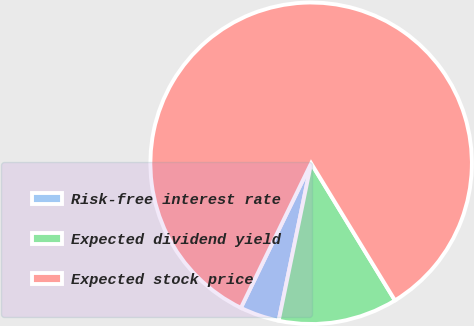Convert chart to OTSL. <chart><loc_0><loc_0><loc_500><loc_500><pie_chart><fcel>Risk-free interest rate<fcel>Expected dividend yield<fcel>Expected stock price<nl><fcel>3.96%<fcel>11.97%<fcel>84.07%<nl></chart> 